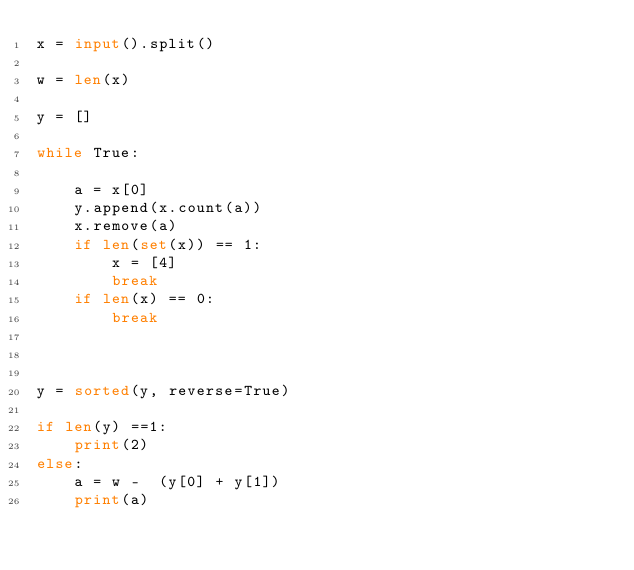Convert code to text. <code><loc_0><loc_0><loc_500><loc_500><_Python_>x = input().split()

w = len(x)

y = []

while True:
    
    a = x[0]
    y.append(x.count(a))
    x.remove(a)
    if len(set(x)) == 1:
        x = [4]
        break
    if len(x) == 0:
        break



y = sorted(y, reverse=True)

if len(y) ==1:
    print(2)
else:
    a = w -  (y[0] + y[1])
    print(a)

    </code> 